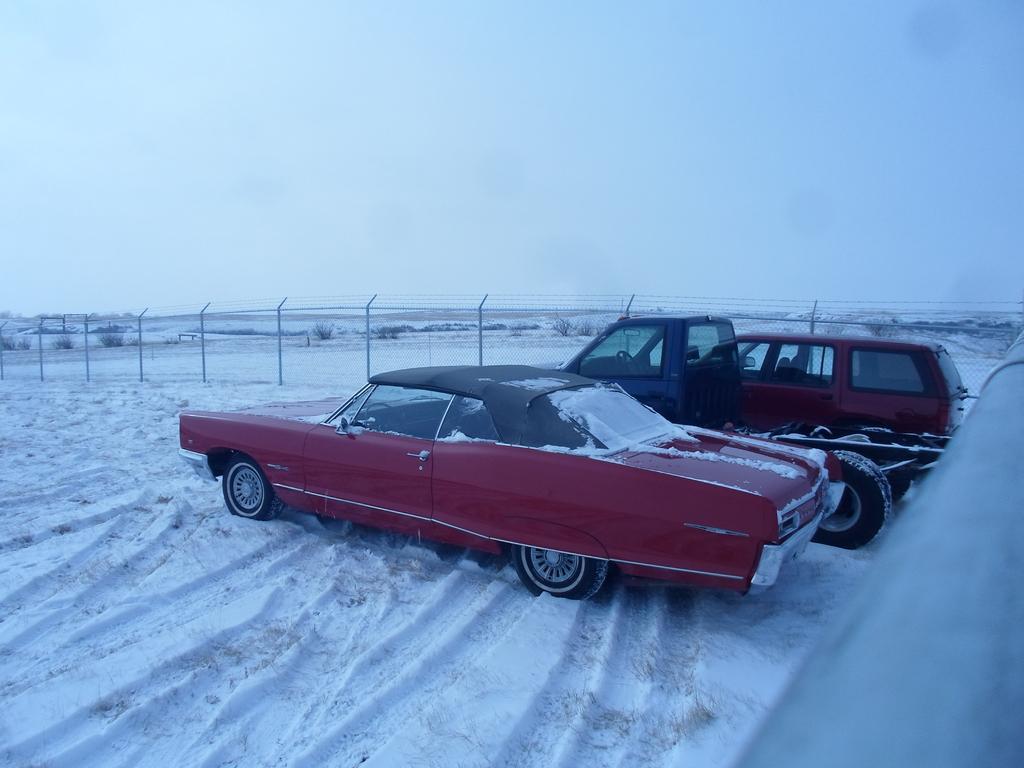Could you give a brief overview of what you see in this image? In this picture there is a red car, beside that we can see a truck and the van. At the bottom we can see the snow. On the left we can see the fencing. In the background we can see many plants and grass. At the top we can see sky and clouds. 